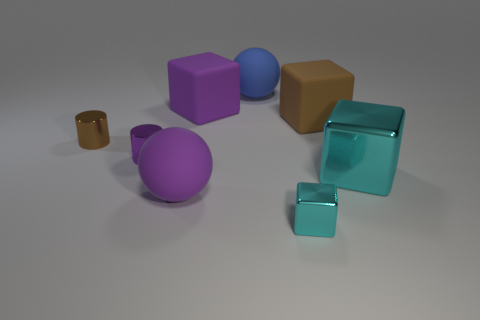Are there an equal number of purple matte things in front of the small brown metal cylinder and big gray shiny objects?
Offer a terse response. No. What number of things are metallic things on the left side of the big cyan shiny object or large gray shiny blocks?
Make the answer very short. 3. There is a thing that is to the right of the small cube and behind the small brown metal cylinder; what shape is it?
Your answer should be very brief. Cube. What number of objects are either large objects in front of the blue sphere or spheres that are in front of the big cyan block?
Offer a very short reply. 4. What number of other objects are there of the same size as the brown cube?
Your answer should be very brief. 4. Do the metal block that is behind the large purple ball and the small shiny block have the same color?
Your answer should be very brief. Yes. What size is the matte thing that is both to the right of the purple rubber cube and on the left side of the small cyan metallic thing?
Ensure brevity in your answer.  Large. How many big things are either brown cylinders or brown matte objects?
Make the answer very short. 1. There is a large cyan metallic thing in front of the big brown matte cube; what is its shape?
Ensure brevity in your answer.  Cube. What number of green metal blocks are there?
Provide a short and direct response. 0. 